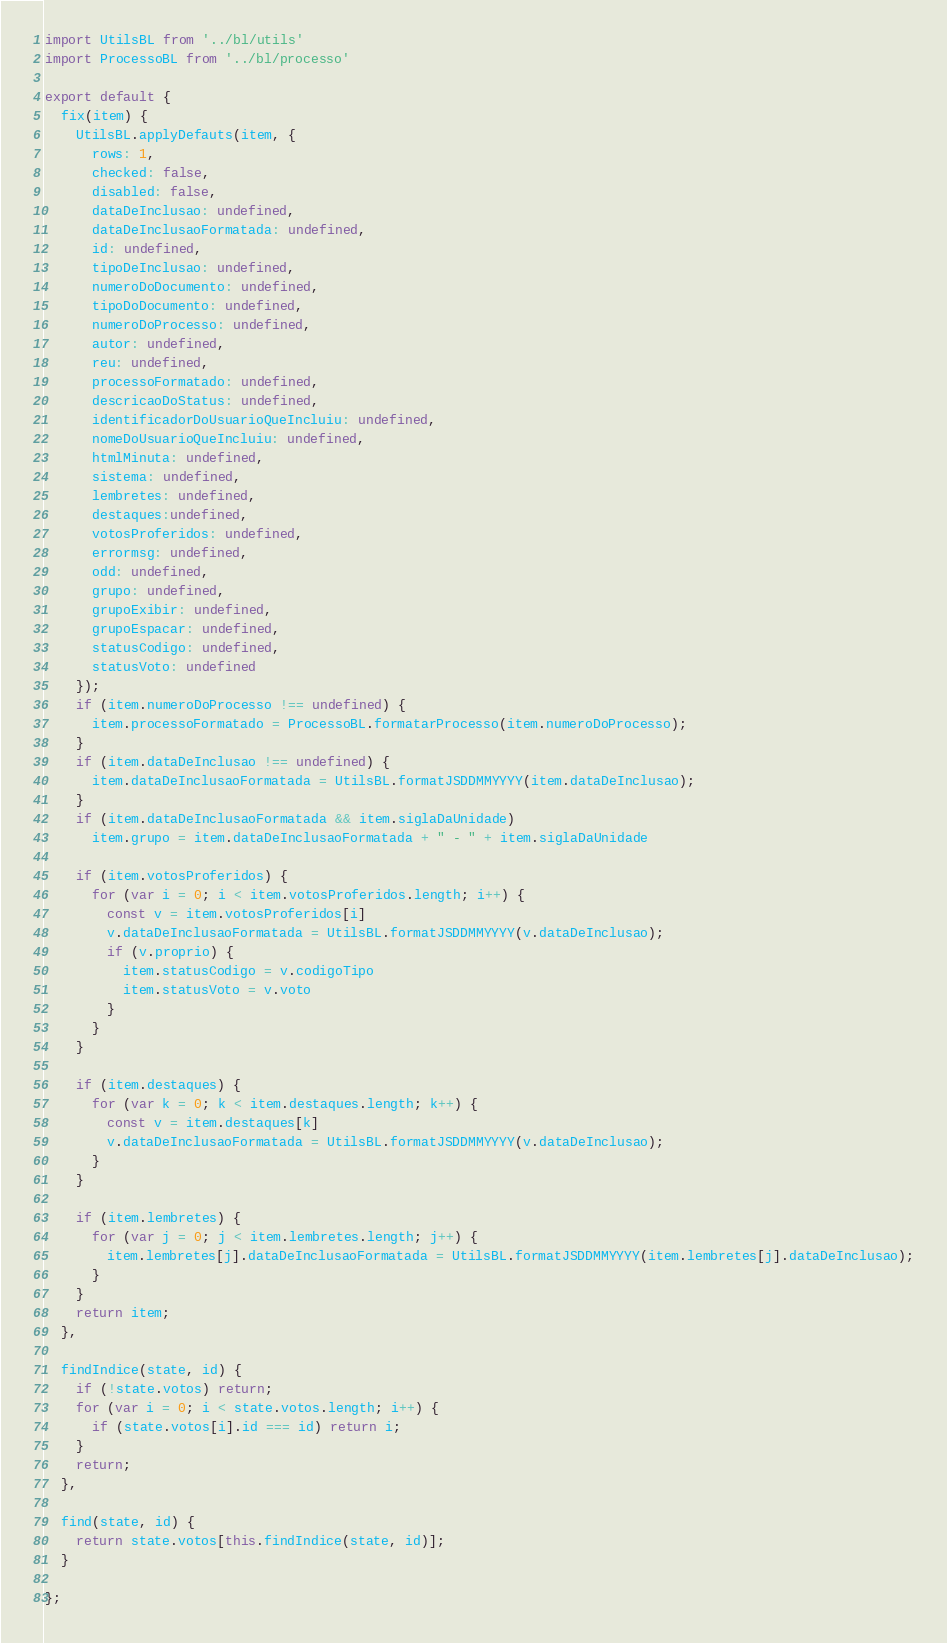Convert code to text. <code><loc_0><loc_0><loc_500><loc_500><_JavaScript_>import UtilsBL from '../bl/utils'
import ProcessoBL from '../bl/processo'

export default {
  fix(item) {
    UtilsBL.applyDefauts(item, {
      rows: 1,
      checked: false,
      disabled: false,
      dataDeInclusao: undefined,
      dataDeInclusaoFormatada: undefined,
      id: undefined,
      tipoDeInclusao: undefined,
      numeroDoDocumento: undefined,
      tipoDoDocumento: undefined,
      numeroDoProcesso: undefined,
      autor: undefined,
      reu: undefined,
      processoFormatado: undefined,
      descricaoDoStatus: undefined,
      identificadorDoUsuarioQueIncluiu: undefined,
      nomeDoUsuarioQueIncluiu: undefined,
      htmlMinuta: undefined,
      sistema: undefined,
      lembretes: undefined,
      destaques:undefined,
      votosProferidos: undefined,
      errormsg: undefined,
      odd: undefined,
      grupo: undefined,
      grupoExibir: undefined,
      grupoEspacar: undefined,
      statusCodigo: undefined,
      statusVoto: undefined
    });
    if (item.numeroDoProcesso !== undefined) {
      item.processoFormatado = ProcessoBL.formatarProcesso(item.numeroDoProcesso);
    }
    if (item.dataDeInclusao !== undefined) {
      item.dataDeInclusaoFormatada = UtilsBL.formatJSDDMMYYYY(item.dataDeInclusao);
    }
    if (item.dataDeInclusaoFormatada && item.siglaDaUnidade)
      item.grupo = item.dataDeInclusaoFormatada + " - " + item.siglaDaUnidade

    if (item.votosProferidos) {
      for (var i = 0; i < item.votosProferidos.length; i++) {
        const v = item.votosProferidos[i]
        v.dataDeInclusaoFormatada = UtilsBL.formatJSDDMMYYYY(v.dataDeInclusao);
        if (v.proprio) {
          item.statusCodigo = v.codigoTipo
          item.statusVoto = v.voto
        }
      }
    }

    if (item.destaques) {
      for (var k = 0; k < item.destaques.length; k++) {
        const v = item.destaques[k]
        v.dataDeInclusaoFormatada = UtilsBL.formatJSDDMMYYYY(v.dataDeInclusao);
      }
    }

    if (item.lembretes) {
      for (var j = 0; j < item.lembretes.length; j++) {
        item.lembretes[j].dataDeInclusaoFormatada = UtilsBL.formatJSDDMMYYYY(item.lembretes[j].dataDeInclusao);
      }
    }
    return item;
  },

  findIndice(state, id) {
    if (!state.votos) return;
    for (var i = 0; i < state.votos.length; i++) {
      if (state.votos[i].id === id) return i;
    }
    return;
  },

  find(state, id) {
    return state.votos[this.findIndice(state, id)];
  }

};</code> 